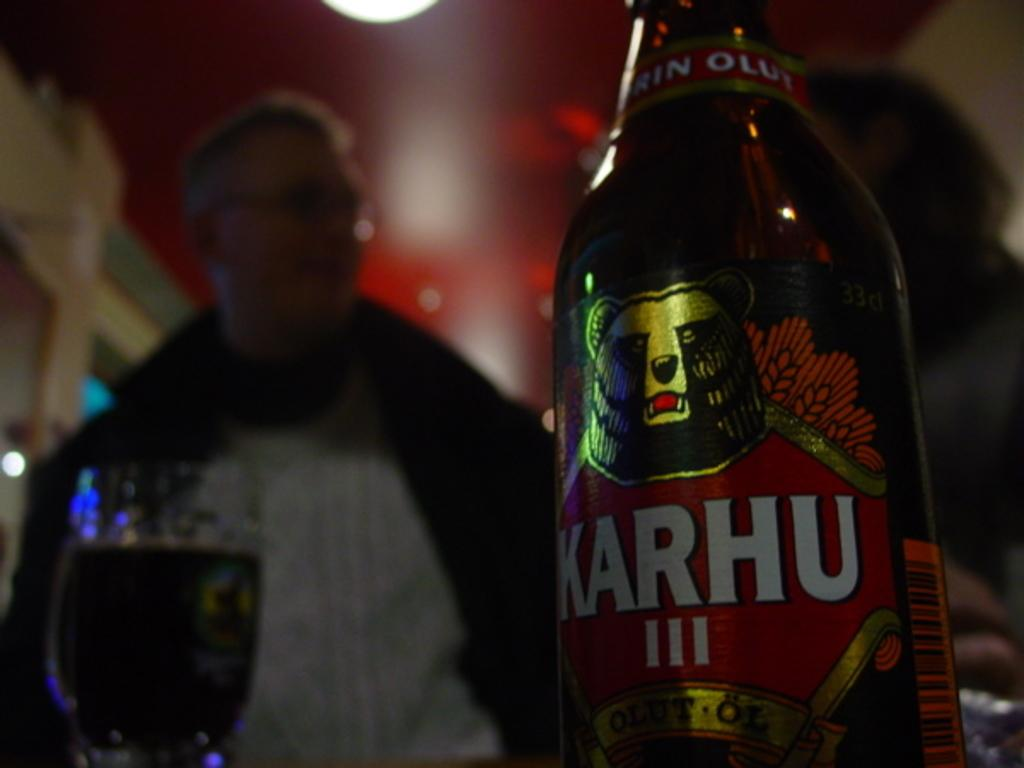<image>
Create a compact narrative representing the image presented. A couple enjoying a night out in a pub with Karhu beer sitting on the table. 